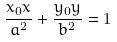Convert formula to latex. <formula><loc_0><loc_0><loc_500><loc_500>\frac { x _ { 0 } x } { a ^ { 2 } } + \frac { y _ { 0 } y } { b ^ { 2 } } = 1</formula> 